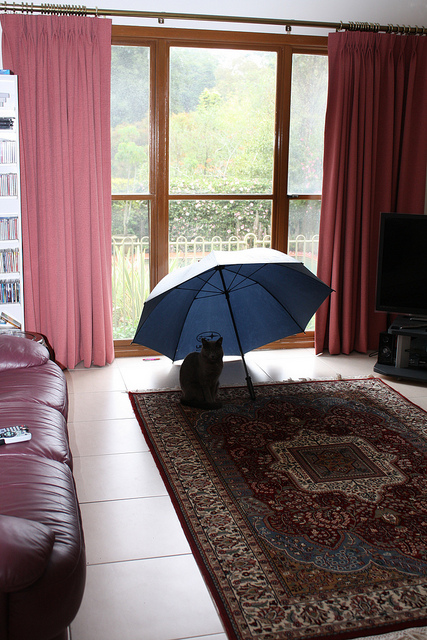How many people on the court are in orange? The image shows a living room with no people visible. Instead, there's a cat sitting under a blue umbrella on a rug. There are no people on a court, and certainly none wearing orange, in this scene. 